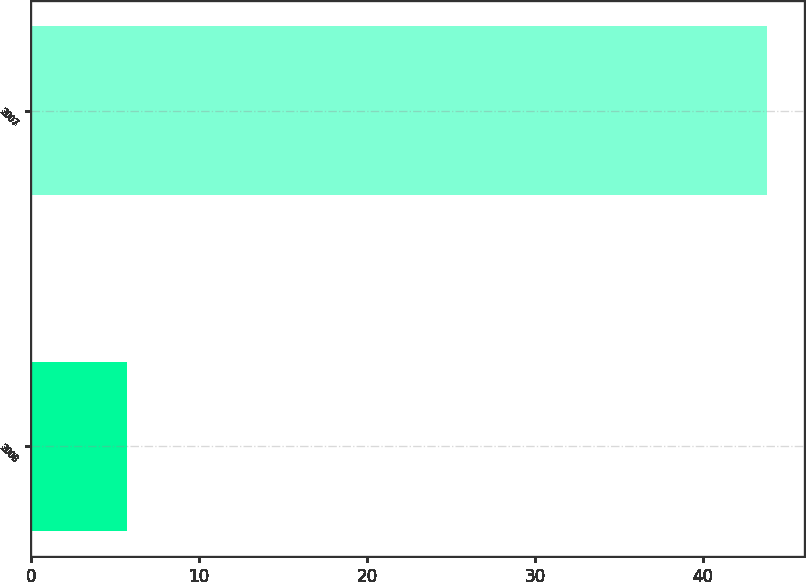Convert chart to OTSL. <chart><loc_0><loc_0><loc_500><loc_500><bar_chart><fcel>2008<fcel>2007<nl><fcel>5.7<fcel>43.8<nl></chart> 